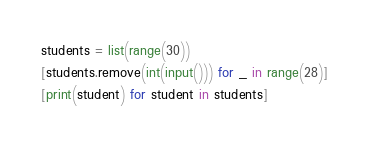Convert code to text. <code><loc_0><loc_0><loc_500><loc_500><_Python_>students = list(range(30))
[students.remove(int(input())) for _ in range(28)] 
[print(student) for student in students]</code> 